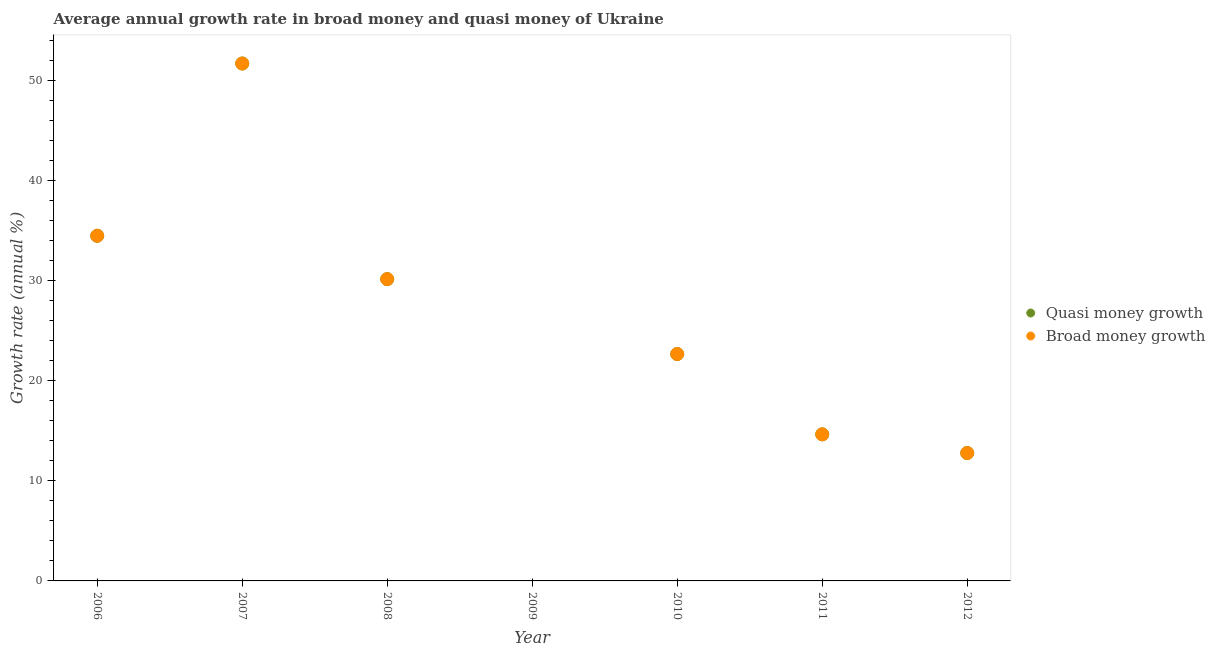What is the annual growth rate in quasi money in 2007?
Keep it short and to the point. 51.75. Across all years, what is the maximum annual growth rate in broad money?
Provide a short and direct response. 51.75. Across all years, what is the minimum annual growth rate in broad money?
Offer a very short reply. 0. What is the total annual growth rate in quasi money in the graph?
Ensure brevity in your answer.  166.59. What is the difference between the annual growth rate in quasi money in 2006 and that in 2010?
Provide a succinct answer. 11.83. What is the difference between the annual growth rate in broad money in 2006 and the annual growth rate in quasi money in 2009?
Provide a succinct answer. 34.52. What is the average annual growth rate in quasi money per year?
Provide a short and direct response. 23.8. In how many years, is the annual growth rate in quasi money greater than 30 %?
Ensure brevity in your answer.  3. What is the ratio of the annual growth rate in quasi money in 2006 to that in 2007?
Make the answer very short. 0.67. What is the difference between the highest and the second highest annual growth rate in quasi money?
Your response must be concise. 17.23. What is the difference between the highest and the lowest annual growth rate in quasi money?
Make the answer very short. 51.75. In how many years, is the annual growth rate in quasi money greater than the average annual growth rate in quasi money taken over all years?
Keep it short and to the point. 3. Is the sum of the annual growth rate in broad money in 2006 and 2008 greater than the maximum annual growth rate in quasi money across all years?
Provide a short and direct response. Yes. Does the annual growth rate in quasi money monotonically increase over the years?
Make the answer very short. No. How many dotlines are there?
Provide a succinct answer. 2. How many years are there in the graph?
Your answer should be compact. 7. Does the graph contain any zero values?
Your answer should be compact. Yes. How many legend labels are there?
Keep it short and to the point. 2. What is the title of the graph?
Your answer should be compact. Average annual growth rate in broad money and quasi money of Ukraine. Does "Constant 2005 US$" appear as one of the legend labels in the graph?
Offer a very short reply. No. What is the label or title of the X-axis?
Your response must be concise. Year. What is the label or title of the Y-axis?
Make the answer very short. Growth rate (annual %). What is the Growth rate (annual %) of Quasi money growth in 2006?
Provide a succinct answer. 34.52. What is the Growth rate (annual %) in Broad money growth in 2006?
Ensure brevity in your answer.  34.52. What is the Growth rate (annual %) in Quasi money growth in 2007?
Give a very brief answer. 51.75. What is the Growth rate (annual %) of Broad money growth in 2007?
Your answer should be compact. 51.75. What is the Growth rate (annual %) in Quasi money growth in 2008?
Offer a terse response. 30.18. What is the Growth rate (annual %) in Broad money growth in 2008?
Your answer should be compact. 30.18. What is the Growth rate (annual %) of Quasi money growth in 2009?
Your response must be concise. 0. What is the Growth rate (annual %) of Quasi money growth in 2010?
Provide a succinct answer. 22.69. What is the Growth rate (annual %) in Broad money growth in 2010?
Keep it short and to the point. 22.69. What is the Growth rate (annual %) in Quasi money growth in 2011?
Make the answer very short. 14.66. What is the Growth rate (annual %) of Broad money growth in 2011?
Make the answer very short. 14.66. What is the Growth rate (annual %) in Quasi money growth in 2012?
Offer a very short reply. 12.79. What is the Growth rate (annual %) in Broad money growth in 2012?
Offer a terse response. 12.79. Across all years, what is the maximum Growth rate (annual %) in Quasi money growth?
Your answer should be very brief. 51.75. Across all years, what is the maximum Growth rate (annual %) in Broad money growth?
Provide a short and direct response. 51.75. What is the total Growth rate (annual %) in Quasi money growth in the graph?
Provide a short and direct response. 166.59. What is the total Growth rate (annual %) in Broad money growth in the graph?
Make the answer very short. 166.59. What is the difference between the Growth rate (annual %) in Quasi money growth in 2006 and that in 2007?
Make the answer very short. -17.23. What is the difference between the Growth rate (annual %) in Broad money growth in 2006 and that in 2007?
Make the answer very short. -17.23. What is the difference between the Growth rate (annual %) of Quasi money growth in 2006 and that in 2008?
Your response must be concise. 4.34. What is the difference between the Growth rate (annual %) of Broad money growth in 2006 and that in 2008?
Provide a short and direct response. 4.34. What is the difference between the Growth rate (annual %) in Quasi money growth in 2006 and that in 2010?
Provide a short and direct response. 11.83. What is the difference between the Growth rate (annual %) in Broad money growth in 2006 and that in 2010?
Make the answer very short. 11.83. What is the difference between the Growth rate (annual %) of Quasi money growth in 2006 and that in 2011?
Your response must be concise. 19.86. What is the difference between the Growth rate (annual %) in Broad money growth in 2006 and that in 2011?
Provide a short and direct response. 19.86. What is the difference between the Growth rate (annual %) of Quasi money growth in 2006 and that in 2012?
Offer a terse response. 21.73. What is the difference between the Growth rate (annual %) in Broad money growth in 2006 and that in 2012?
Make the answer very short. 21.73. What is the difference between the Growth rate (annual %) in Quasi money growth in 2007 and that in 2008?
Your answer should be compact. 21.56. What is the difference between the Growth rate (annual %) of Broad money growth in 2007 and that in 2008?
Make the answer very short. 21.56. What is the difference between the Growth rate (annual %) of Quasi money growth in 2007 and that in 2010?
Provide a short and direct response. 29.06. What is the difference between the Growth rate (annual %) in Broad money growth in 2007 and that in 2010?
Offer a very short reply. 29.06. What is the difference between the Growth rate (annual %) of Quasi money growth in 2007 and that in 2011?
Your response must be concise. 37.09. What is the difference between the Growth rate (annual %) of Broad money growth in 2007 and that in 2011?
Ensure brevity in your answer.  37.09. What is the difference between the Growth rate (annual %) in Quasi money growth in 2007 and that in 2012?
Keep it short and to the point. 38.96. What is the difference between the Growth rate (annual %) of Broad money growth in 2007 and that in 2012?
Keep it short and to the point. 38.96. What is the difference between the Growth rate (annual %) in Quasi money growth in 2008 and that in 2010?
Your response must be concise. 7.49. What is the difference between the Growth rate (annual %) in Broad money growth in 2008 and that in 2010?
Provide a short and direct response. 7.49. What is the difference between the Growth rate (annual %) in Quasi money growth in 2008 and that in 2011?
Your answer should be very brief. 15.52. What is the difference between the Growth rate (annual %) in Broad money growth in 2008 and that in 2011?
Make the answer very short. 15.52. What is the difference between the Growth rate (annual %) in Quasi money growth in 2008 and that in 2012?
Provide a succinct answer. 17.39. What is the difference between the Growth rate (annual %) in Broad money growth in 2008 and that in 2012?
Ensure brevity in your answer.  17.39. What is the difference between the Growth rate (annual %) in Quasi money growth in 2010 and that in 2011?
Provide a succinct answer. 8.03. What is the difference between the Growth rate (annual %) of Broad money growth in 2010 and that in 2011?
Keep it short and to the point. 8.03. What is the difference between the Growth rate (annual %) of Quasi money growth in 2010 and that in 2012?
Provide a short and direct response. 9.9. What is the difference between the Growth rate (annual %) of Broad money growth in 2010 and that in 2012?
Provide a short and direct response. 9.9. What is the difference between the Growth rate (annual %) of Quasi money growth in 2011 and that in 2012?
Make the answer very short. 1.87. What is the difference between the Growth rate (annual %) of Broad money growth in 2011 and that in 2012?
Ensure brevity in your answer.  1.87. What is the difference between the Growth rate (annual %) in Quasi money growth in 2006 and the Growth rate (annual %) in Broad money growth in 2007?
Keep it short and to the point. -17.23. What is the difference between the Growth rate (annual %) of Quasi money growth in 2006 and the Growth rate (annual %) of Broad money growth in 2008?
Your response must be concise. 4.34. What is the difference between the Growth rate (annual %) of Quasi money growth in 2006 and the Growth rate (annual %) of Broad money growth in 2010?
Your answer should be compact. 11.83. What is the difference between the Growth rate (annual %) of Quasi money growth in 2006 and the Growth rate (annual %) of Broad money growth in 2011?
Keep it short and to the point. 19.86. What is the difference between the Growth rate (annual %) in Quasi money growth in 2006 and the Growth rate (annual %) in Broad money growth in 2012?
Offer a very short reply. 21.73. What is the difference between the Growth rate (annual %) of Quasi money growth in 2007 and the Growth rate (annual %) of Broad money growth in 2008?
Provide a succinct answer. 21.56. What is the difference between the Growth rate (annual %) of Quasi money growth in 2007 and the Growth rate (annual %) of Broad money growth in 2010?
Your response must be concise. 29.06. What is the difference between the Growth rate (annual %) in Quasi money growth in 2007 and the Growth rate (annual %) in Broad money growth in 2011?
Your response must be concise. 37.09. What is the difference between the Growth rate (annual %) of Quasi money growth in 2007 and the Growth rate (annual %) of Broad money growth in 2012?
Ensure brevity in your answer.  38.96. What is the difference between the Growth rate (annual %) in Quasi money growth in 2008 and the Growth rate (annual %) in Broad money growth in 2010?
Your response must be concise. 7.49. What is the difference between the Growth rate (annual %) of Quasi money growth in 2008 and the Growth rate (annual %) of Broad money growth in 2011?
Provide a succinct answer. 15.52. What is the difference between the Growth rate (annual %) in Quasi money growth in 2008 and the Growth rate (annual %) in Broad money growth in 2012?
Offer a terse response. 17.39. What is the difference between the Growth rate (annual %) of Quasi money growth in 2010 and the Growth rate (annual %) of Broad money growth in 2011?
Offer a very short reply. 8.03. What is the difference between the Growth rate (annual %) in Quasi money growth in 2010 and the Growth rate (annual %) in Broad money growth in 2012?
Your answer should be compact. 9.9. What is the difference between the Growth rate (annual %) of Quasi money growth in 2011 and the Growth rate (annual %) of Broad money growth in 2012?
Ensure brevity in your answer.  1.87. What is the average Growth rate (annual %) of Quasi money growth per year?
Your answer should be compact. 23.8. What is the average Growth rate (annual %) of Broad money growth per year?
Provide a succinct answer. 23.8. What is the ratio of the Growth rate (annual %) in Quasi money growth in 2006 to that in 2007?
Make the answer very short. 0.67. What is the ratio of the Growth rate (annual %) of Broad money growth in 2006 to that in 2007?
Make the answer very short. 0.67. What is the ratio of the Growth rate (annual %) of Quasi money growth in 2006 to that in 2008?
Provide a succinct answer. 1.14. What is the ratio of the Growth rate (annual %) of Broad money growth in 2006 to that in 2008?
Give a very brief answer. 1.14. What is the ratio of the Growth rate (annual %) of Quasi money growth in 2006 to that in 2010?
Make the answer very short. 1.52. What is the ratio of the Growth rate (annual %) of Broad money growth in 2006 to that in 2010?
Your response must be concise. 1.52. What is the ratio of the Growth rate (annual %) in Quasi money growth in 2006 to that in 2011?
Provide a short and direct response. 2.35. What is the ratio of the Growth rate (annual %) of Broad money growth in 2006 to that in 2011?
Your response must be concise. 2.35. What is the ratio of the Growth rate (annual %) in Quasi money growth in 2006 to that in 2012?
Your answer should be very brief. 2.7. What is the ratio of the Growth rate (annual %) of Broad money growth in 2006 to that in 2012?
Make the answer very short. 2.7. What is the ratio of the Growth rate (annual %) of Quasi money growth in 2007 to that in 2008?
Ensure brevity in your answer.  1.71. What is the ratio of the Growth rate (annual %) in Broad money growth in 2007 to that in 2008?
Offer a terse response. 1.71. What is the ratio of the Growth rate (annual %) of Quasi money growth in 2007 to that in 2010?
Offer a terse response. 2.28. What is the ratio of the Growth rate (annual %) of Broad money growth in 2007 to that in 2010?
Your answer should be very brief. 2.28. What is the ratio of the Growth rate (annual %) in Quasi money growth in 2007 to that in 2011?
Provide a succinct answer. 3.53. What is the ratio of the Growth rate (annual %) of Broad money growth in 2007 to that in 2011?
Your answer should be compact. 3.53. What is the ratio of the Growth rate (annual %) of Quasi money growth in 2007 to that in 2012?
Make the answer very short. 4.05. What is the ratio of the Growth rate (annual %) in Broad money growth in 2007 to that in 2012?
Offer a terse response. 4.05. What is the ratio of the Growth rate (annual %) of Quasi money growth in 2008 to that in 2010?
Your answer should be compact. 1.33. What is the ratio of the Growth rate (annual %) in Broad money growth in 2008 to that in 2010?
Ensure brevity in your answer.  1.33. What is the ratio of the Growth rate (annual %) in Quasi money growth in 2008 to that in 2011?
Offer a terse response. 2.06. What is the ratio of the Growth rate (annual %) of Broad money growth in 2008 to that in 2011?
Give a very brief answer. 2.06. What is the ratio of the Growth rate (annual %) in Quasi money growth in 2008 to that in 2012?
Give a very brief answer. 2.36. What is the ratio of the Growth rate (annual %) in Broad money growth in 2008 to that in 2012?
Your response must be concise. 2.36. What is the ratio of the Growth rate (annual %) of Quasi money growth in 2010 to that in 2011?
Your answer should be compact. 1.55. What is the ratio of the Growth rate (annual %) of Broad money growth in 2010 to that in 2011?
Give a very brief answer. 1.55. What is the ratio of the Growth rate (annual %) of Quasi money growth in 2010 to that in 2012?
Provide a succinct answer. 1.77. What is the ratio of the Growth rate (annual %) of Broad money growth in 2010 to that in 2012?
Your response must be concise. 1.77. What is the ratio of the Growth rate (annual %) in Quasi money growth in 2011 to that in 2012?
Provide a succinct answer. 1.15. What is the ratio of the Growth rate (annual %) in Broad money growth in 2011 to that in 2012?
Ensure brevity in your answer.  1.15. What is the difference between the highest and the second highest Growth rate (annual %) of Quasi money growth?
Offer a very short reply. 17.23. What is the difference between the highest and the second highest Growth rate (annual %) in Broad money growth?
Keep it short and to the point. 17.23. What is the difference between the highest and the lowest Growth rate (annual %) of Quasi money growth?
Keep it short and to the point. 51.75. What is the difference between the highest and the lowest Growth rate (annual %) in Broad money growth?
Your answer should be very brief. 51.75. 